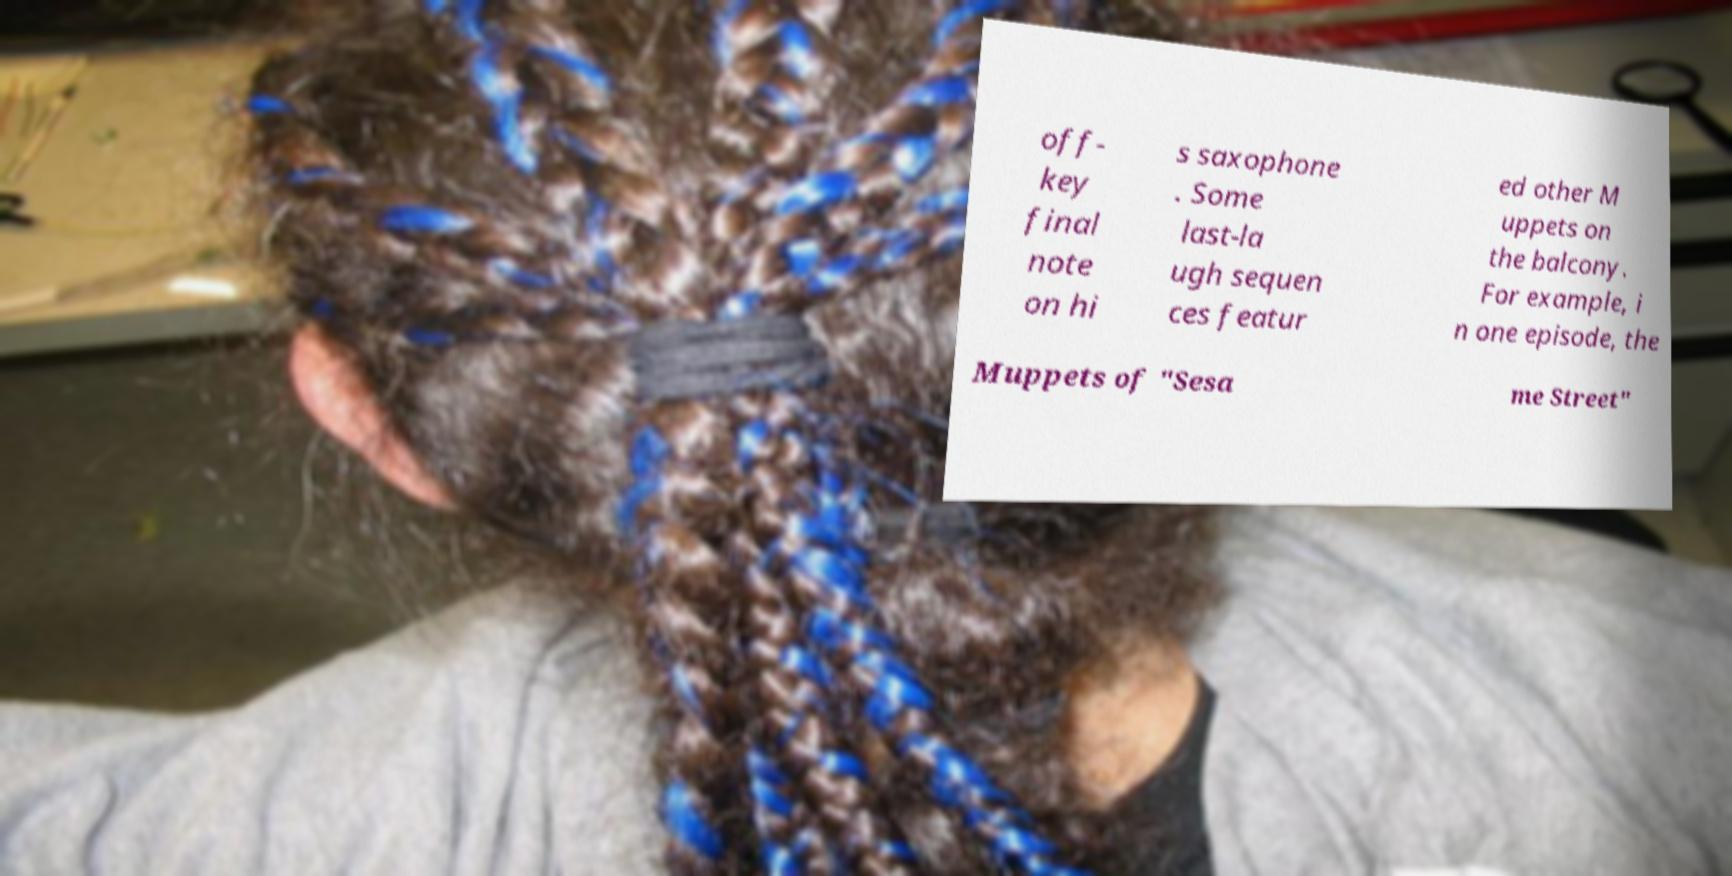Please identify and transcribe the text found in this image. off- key final note on hi s saxophone . Some last-la ugh sequen ces featur ed other M uppets on the balcony. For example, i n one episode, the Muppets of "Sesa me Street" 